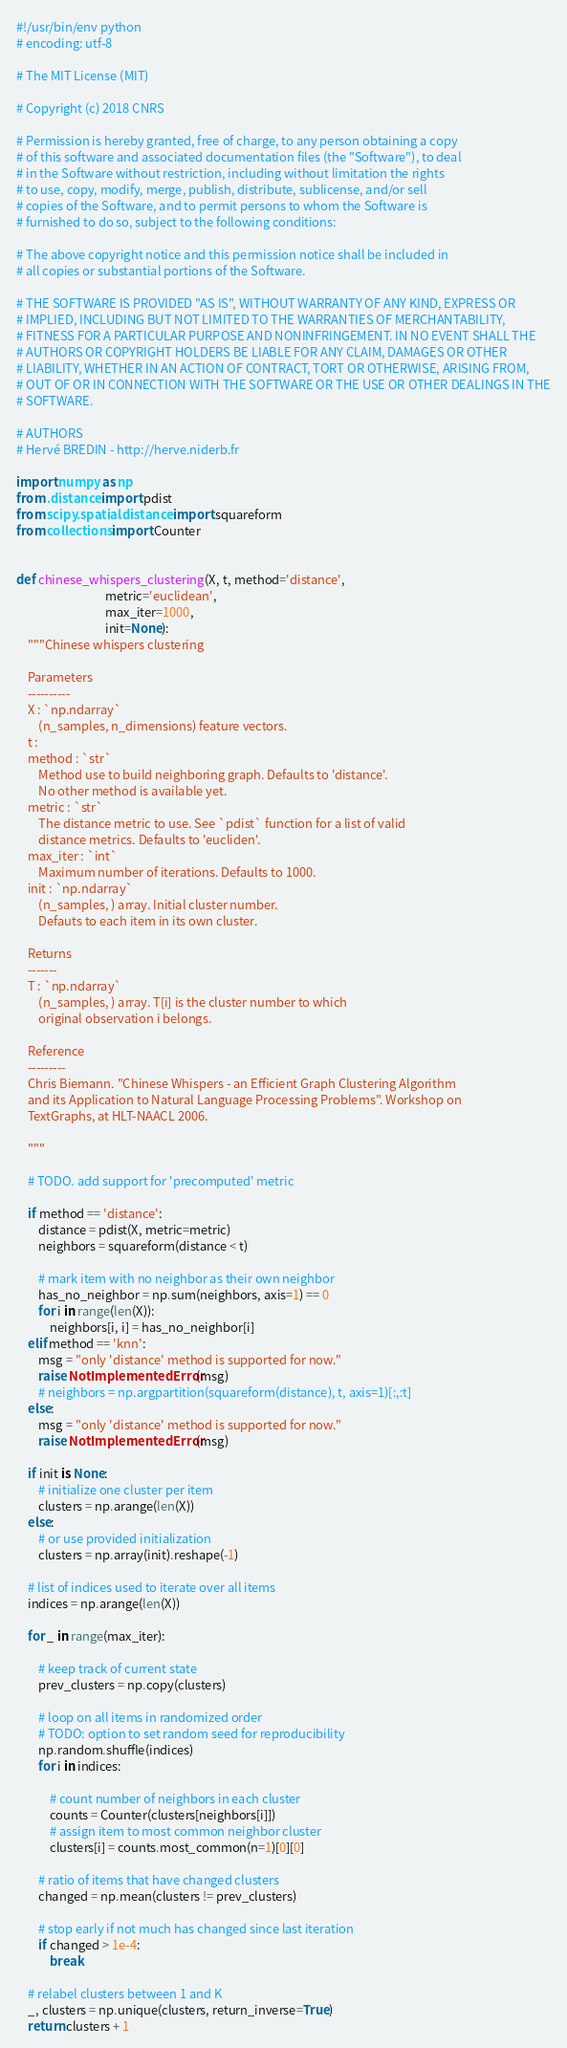<code> <loc_0><loc_0><loc_500><loc_500><_Python_>#!/usr/bin/env python
# encoding: utf-8

# The MIT License (MIT)

# Copyright (c) 2018 CNRS

# Permission is hereby granted, free of charge, to any person obtaining a copy
# of this software and associated documentation files (the "Software"), to deal
# in the Software without restriction, including without limitation the rights
# to use, copy, modify, merge, publish, distribute, sublicense, and/or sell
# copies of the Software, and to permit persons to whom the Software is
# furnished to do so, subject to the following conditions:

# The above copyright notice and this permission notice shall be included in
# all copies or substantial portions of the Software.

# THE SOFTWARE IS PROVIDED "AS IS", WITHOUT WARRANTY OF ANY KIND, EXPRESS OR
# IMPLIED, INCLUDING BUT NOT LIMITED TO THE WARRANTIES OF MERCHANTABILITY,
# FITNESS FOR A PARTICULAR PURPOSE AND NONINFRINGEMENT. IN NO EVENT SHALL THE
# AUTHORS OR COPYRIGHT HOLDERS BE LIABLE FOR ANY CLAIM, DAMAGES OR OTHER
# LIABILITY, WHETHER IN AN ACTION OF CONTRACT, TORT OR OTHERWISE, ARISING FROM,
# OUT OF OR IN CONNECTION WITH THE SOFTWARE OR THE USE OR OTHER DEALINGS IN THE
# SOFTWARE.

# AUTHORS
# Hervé BREDIN - http://herve.niderb.fr

import numpy as np
from .distance import pdist
from scipy.spatial.distance import squareform
from collections import Counter


def chinese_whispers_clustering(X, t, method='distance',
                                metric='euclidean',
                                max_iter=1000,
                                init=None):
    """Chinese whispers clustering

    Parameters
    ----------
    X : `np.ndarray`
        (n_samples, n_dimensions) feature vectors.
    t :
    method : `str`
        Method use to build neighboring graph. Defaults to 'distance'.
        No other method is available yet.
    metric : `str`
        The distance metric to use. See `pdist` function for a list of valid
        distance metrics. Defaults to 'eucliden'.
    max_iter : `int`
        Maximum number of iterations. Defaults to 1000.
    init : `np.ndarray`
        (n_samples, ) array. Initial cluster number.
        Defauts to each item in its own cluster.

    Returns
    -------
    T : `np.ndarray`
        (n_samples, ) array. T[i] is the cluster number to which
        original observation i belongs.

    Reference
    ---------
    Chris Biemann. "Chinese Whispers - an Efficient Graph Clustering Algorithm
    and its Application to Natural Language Processing Problems". Workshop on
    TextGraphs, at HLT-NAACL 2006.

    """

    # TODO. add support for 'precomputed' metric

    if method == 'distance':
        distance = pdist(X, metric=metric)
        neighbors = squareform(distance < t)

        # mark item with no neighbor as their own neighbor
        has_no_neighbor = np.sum(neighbors, axis=1) == 0
        for i in range(len(X)):
            neighbors[i, i] = has_no_neighbor[i]
    elif method == 'knn':
        msg = "only 'distance' method is supported for now."
        raise NotImplementedError(msg)
        # neighbors = np.argpartition(squareform(distance), t, axis=1)[:,:t]
    else:
        msg = "only 'distance' method is supported for now."
        raise NotImplementedError(msg)

    if init is None:
        # initialize one cluster per item
        clusters = np.arange(len(X))
    else:
        # or use provided initialization
        clusters = np.array(init).reshape(-1)

    # list of indices used to iterate over all items
    indices = np.arange(len(X))

    for _ in range(max_iter):

        # keep track of current state
        prev_clusters = np.copy(clusters)

        # loop on all items in randomized order
        # TODO: option to set random seed for reproducibility
        np.random.shuffle(indices)
        for i in indices:

            # count number of neighbors in each cluster
            counts = Counter(clusters[neighbors[i]])
            # assign item to most common neighbor cluster
            clusters[i] = counts.most_common(n=1)[0][0]

        # ratio of items that have changed clusters
        changed = np.mean(clusters != prev_clusters)

        # stop early if not much has changed since last iteration
        if changed > 1e-4:
            break

    # relabel clusters between 1 and K
    _, clusters = np.unique(clusters, return_inverse=True)
    return clusters + 1
</code> 